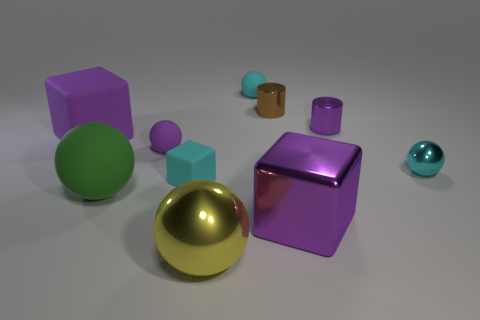Subtract all green spheres. How many spheres are left? 4 Subtract all big matte spheres. How many spheres are left? 4 Subtract all gray balls. Subtract all cyan cylinders. How many balls are left? 5 Subtract all cylinders. How many objects are left? 8 Subtract 1 yellow balls. How many objects are left? 9 Subtract all tiny cyan things. Subtract all tiny yellow objects. How many objects are left? 7 Add 7 purple rubber things. How many purple rubber things are left? 9 Add 5 tiny purple metallic cylinders. How many tiny purple metallic cylinders exist? 6 